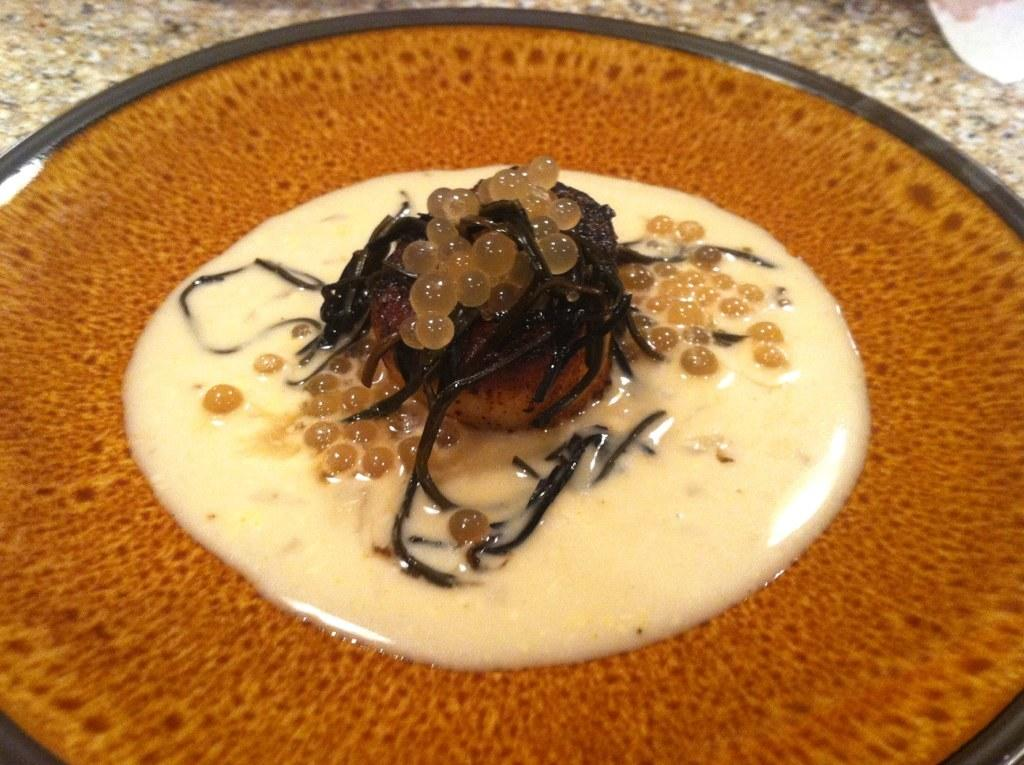What is the main subject of the image? The main subject of the image is food. Can you describe the colors of the food in the image? The food has brown, cream, and black colors. What type of wave can be seen crashing on the shore in the image? There is no wave or shore present in the image; it features food with brown, cream, and black colors. What type of soap is being used to clean the structure in the image? There is no soap or structure present in the image. 